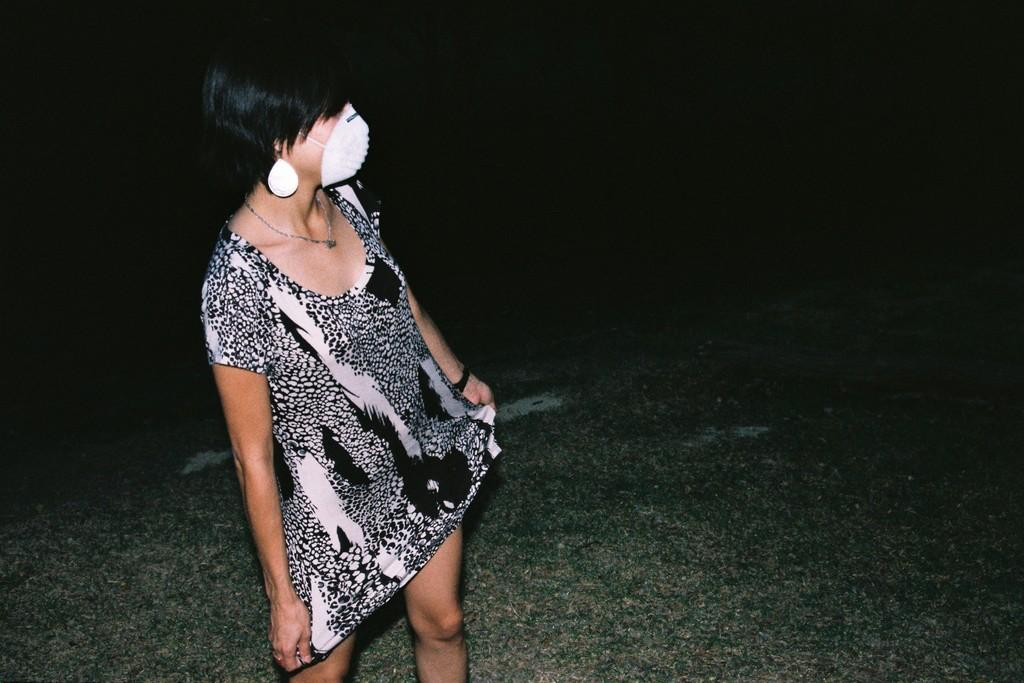What is the main subject of the image? The main subject of the image is a woman standing. What is the woman wearing on her face? The woman is wearing a mask on her face. What type of ground is visible in the image? There is grass on the ground in the image. How would you describe the background of the image? The background of the image is dark. What word is written on the potato in the image? There is no potato present in the image, and therefore no word can be written on it. 